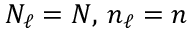Convert formula to latex. <formula><loc_0><loc_0><loc_500><loc_500>N _ { \ell } = N , \, n _ { \ell } = n</formula> 